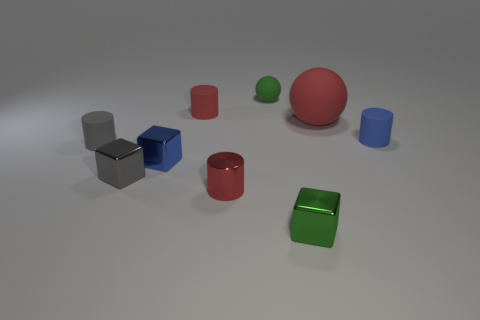Do the tiny cylinder right of the big red rubber thing and the gray cylinder have the same material?
Offer a very short reply. Yes. Are there the same number of tiny blue metal blocks behind the blue block and blue metallic blocks on the right side of the green sphere?
Provide a succinct answer. Yes. Is there any other thing that is the same size as the blue cube?
Make the answer very short. Yes. What is the material of the gray object that is the same shape as the blue metallic thing?
Provide a short and direct response. Metal. There is a tiny blue thing to the right of the tiny green object behind the tiny red matte object; is there a small blue thing that is in front of it?
Your answer should be compact. Yes. There is a small green thing behind the small blue rubber object; is it the same shape as the small shiny thing that is behind the tiny gray block?
Provide a short and direct response. No. Is the number of big red spheres in front of the small blue matte cylinder greater than the number of large cyan shiny balls?
Offer a terse response. No. What number of things are blue shiny things or big yellow objects?
Ensure brevity in your answer.  1. What is the color of the small sphere?
Your response must be concise. Green. What number of other things are the same color as the small metallic cylinder?
Your answer should be very brief. 2. 